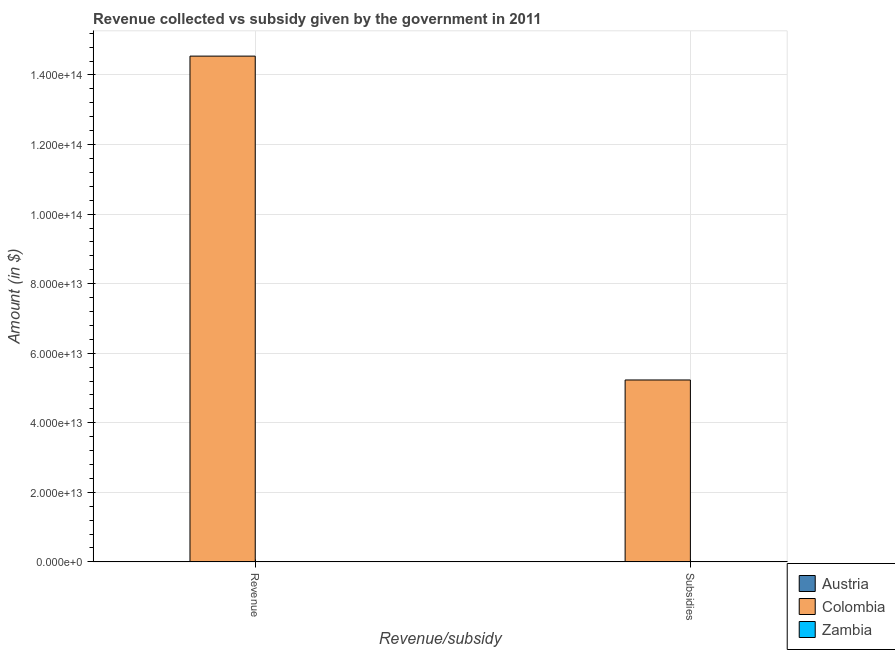Are the number of bars per tick equal to the number of legend labels?
Make the answer very short. Yes. Are the number of bars on each tick of the X-axis equal?
Give a very brief answer. Yes. How many bars are there on the 2nd tick from the left?
Your answer should be very brief. 3. How many bars are there on the 1st tick from the right?
Offer a very short reply. 3. What is the label of the 1st group of bars from the left?
Your answer should be compact. Revenue. What is the amount of revenue collected in Zambia?
Make the answer very short. 1.99e+1. Across all countries, what is the maximum amount of subsidies given?
Make the answer very short. 5.23e+13. Across all countries, what is the minimum amount of revenue collected?
Give a very brief answer. 1.99e+1. In which country was the amount of revenue collected minimum?
Your answer should be very brief. Zambia. What is the total amount of revenue collected in the graph?
Ensure brevity in your answer.  1.46e+14. What is the difference between the amount of revenue collected in Colombia and that in Zambia?
Your answer should be very brief. 1.45e+14. What is the difference between the amount of subsidies given in Zambia and the amount of revenue collected in Austria?
Give a very brief answer. -1.08e+11. What is the average amount of subsidies given per country?
Ensure brevity in your answer.  1.75e+13. What is the difference between the amount of subsidies given and amount of revenue collected in Zambia?
Your response must be concise. -1.92e+1. What is the ratio of the amount of revenue collected in Austria to that in Zambia?
Offer a very short reply. 5.44. What does the 1st bar from the right in Subsidies represents?
Ensure brevity in your answer.  Zambia. How many bars are there?
Offer a terse response. 6. How many countries are there in the graph?
Give a very brief answer. 3. What is the difference between two consecutive major ticks on the Y-axis?
Your answer should be very brief. 2.00e+13. Are the values on the major ticks of Y-axis written in scientific E-notation?
Offer a very short reply. Yes. Does the graph contain any zero values?
Ensure brevity in your answer.  No. How are the legend labels stacked?
Ensure brevity in your answer.  Vertical. What is the title of the graph?
Your answer should be very brief. Revenue collected vs subsidy given by the government in 2011. Does "Pacific island small states" appear as one of the legend labels in the graph?
Offer a terse response. No. What is the label or title of the X-axis?
Offer a terse response. Revenue/subsidy. What is the label or title of the Y-axis?
Your answer should be very brief. Amount (in $). What is the Amount (in $) in Austria in Revenue?
Give a very brief answer. 1.09e+11. What is the Amount (in $) of Colombia in Revenue?
Ensure brevity in your answer.  1.45e+14. What is the Amount (in $) in Zambia in Revenue?
Your answer should be compact. 1.99e+1. What is the Amount (in $) in Austria in Subsidies?
Make the answer very short. 7.95e+1. What is the Amount (in $) of Colombia in Subsidies?
Provide a succinct answer. 5.23e+13. What is the Amount (in $) in Zambia in Subsidies?
Your answer should be very brief. 6.94e+08. Across all Revenue/subsidy, what is the maximum Amount (in $) in Austria?
Your response must be concise. 1.09e+11. Across all Revenue/subsidy, what is the maximum Amount (in $) in Colombia?
Your answer should be compact. 1.45e+14. Across all Revenue/subsidy, what is the maximum Amount (in $) of Zambia?
Give a very brief answer. 1.99e+1. Across all Revenue/subsidy, what is the minimum Amount (in $) of Austria?
Give a very brief answer. 7.95e+1. Across all Revenue/subsidy, what is the minimum Amount (in $) in Colombia?
Offer a very short reply. 5.23e+13. Across all Revenue/subsidy, what is the minimum Amount (in $) of Zambia?
Your answer should be compact. 6.94e+08. What is the total Amount (in $) in Austria in the graph?
Offer a very short reply. 1.88e+11. What is the total Amount (in $) of Colombia in the graph?
Give a very brief answer. 1.98e+14. What is the total Amount (in $) of Zambia in the graph?
Offer a very short reply. 2.06e+1. What is the difference between the Amount (in $) in Austria in Revenue and that in Subsidies?
Ensure brevity in your answer.  2.91e+1. What is the difference between the Amount (in $) of Colombia in Revenue and that in Subsidies?
Your answer should be very brief. 9.31e+13. What is the difference between the Amount (in $) in Zambia in Revenue and that in Subsidies?
Offer a very short reply. 1.92e+1. What is the difference between the Amount (in $) in Austria in Revenue and the Amount (in $) in Colombia in Subsidies?
Offer a very short reply. -5.22e+13. What is the difference between the Amount (in $) in Austria in Revenue and the Amount (in $) in Zambia in Subsidies?
Ensure brevity in your answer.  1.08e+11. What is the difference between the Amount (in $) of Colombia in Revenue and the Amount (in $) of Zambia in Subsidies?
Offer a terse response. 1.45e+14. What is the average Amount (in $) in Austria per Revenue/subsidy?
Keep it short and to the point. 9.40e+1. What is the average Amount (in $) in Colombia per Revenue/subsidy?
Make the answer very short. 9.89e+13. What is the average Amount (in $) in Zambia per Revenue/subsidy?
Offer a very short reply. 1.03e+1. What is the difference between the Amount (in $) in Austria and Amount (in $) in Colombia in Revenue?
Provide a succinct answer. -1.45e+14. What is the difference between the Amount (in $) in Austria and Amount (in $) in Zambia in Revenue?
Ensure brevity in your answer.  8.86e+1. What is the difference between the Amount (in $) of Colombia and Amount (in $) of Zambia in Revenue?
Your response must be concise. 1.45e+14. What is the difference between the Amount (in $) of Austria and Amount (in $) of Colombia in Subsidies?
Your answer should be very brief. -5.22e+13. What is the difference between the Amount (in $) of Austria and Amount (in $) of Zambia in Subsidies?
Your response must be concise. 7.88e+1. What is the difference between the Amount (in $) of Colombia and Amount (in $) of Zambia in Subsidies?
Keep it short and to the point. 5.23e+13. What is the ratio of the Amount (in $) in Austria in Revenue to that in Subsidies?
Provide a short and direct response. 1.37. What is the ratio of the Amount (in $) of Colombia in Revenue to that in Subsidies?
Offer a very short reply. 2.78. What is the ratio of the Amount (in $) in Zambia in Revenue to that in Subsidies?
Your answer should be compact. 28.74. What is the difference between the highest and the second highest Amount (in $) in Austria?
Provide a succinct answer. 2.91e+1. What is the difference between the highest and the second highest Amount (in $) of Colombia?
Provide a short and direct response. 9.31e+13. What is the difference between the highest and the second highest Amount (in $) of Zambia?
Offer a terse response. 1.92e+1. What is the difference between the highest and the lowest Amount (in $) of Austria?
Offer a very short reply. 2.91e+1. What is the difference between the highest and the lowest Amount (in $) of Colombia?
Ensure brevity in your answer.  9.31e+13. What is the difference between the highest and the lowest Amount (in $) in Zambia?
Keep it short and to the point. 1.92e+1. 